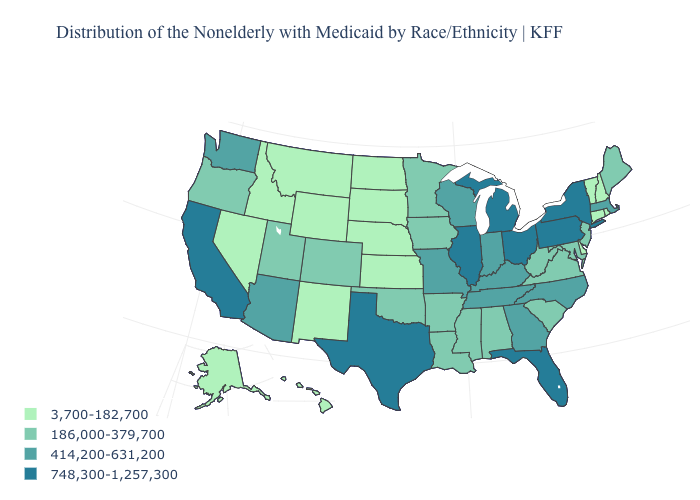Is the legend a continuous bar?
Short answer required. No. Among the states that border West Virginia , which have the highest value?
Short answer required. Ohio, Pennsylvania. What is the value of South Dakota?
Short answer required. 3,700-182,700. Name the states that have a value in the range 3,700-182,700?
Keep it brief. Alaska, Connecticut, Delaware, Hawaii, Idaho, Kansas, Montana, Nebraska, Nevada, New Hampshire, New Mexico, North Dakota, Rhode Island, South Dakota, Vermont, Wyoming. Does the first symbol in the legend represent the smallest category?
Answer briefly. Yes. Does Florida have the highest value in the South?
Quick response, please. Yes. Name the states that have a value in the range 414,200-631,200?
Concise answer only. Arizona, Georgia, Indiana, Kentucky, Massachusetts, Missouri, North Carolina, Tennessee, Washington, Wisconsin. Does Texas have the highest value in the USA?
Be succinct. Yes. What is the highest value in the MidWest ?
Keep it brief. 748,300-1,257,300. Name the states that have a value in the range 186,000-379,700?
Give a very brief answer. Alabama, Arkansas, Colorado, Iowa, Louisiana, Maine, Maryland, Minnesota, Mississippi, New Jersey, Oklahoma, Oregon, South Carolina, Utah, Virginia, West Virginia. What is the lowest value in the Northeast?
Keep it brief. 3,700-182,700. Among the states that border Idaho , which have the lowest value?
Write a very short answer. Montana, Nevada, Wyoming. Name the states that have a value in the range 748,300-1,257,300?
Be succinct. California, Florida, Illinois, Michigan, New York, Ohio, Pennsylvania, Texas. Name the states that have a value in the range 186,000-379,700?
Be succinct. Alabama, Arkansas, Colorado, Iowa, Louisiana, Maine, Maryland, Minnesota, Mississippi, New Jersey, Oklahoma, Oregon, South Carolina, Utah, Virginia, West Virginia. Does California have the lowest value in the USA?
Give a very brief answer. No. 